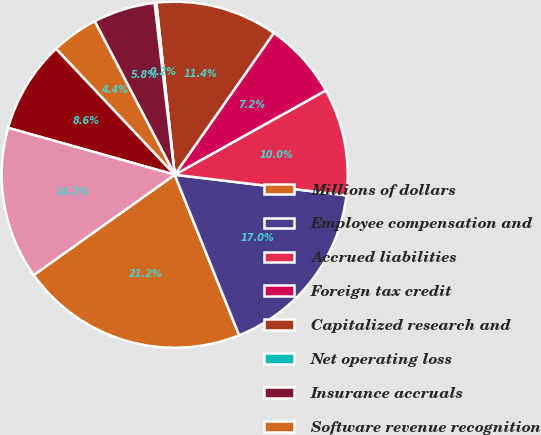Convert chart to OTSL. <chart><loc_0><loc_0><loc_500><loc_500><pie_chart><fcel>Millions of dollars<fcel>Employee compensation and<fcel>Accrued liabilities<fcel>Foreign tax credit<fcel>Capitalized research and<fcel>Net operating loss<fcel>Insurance accruals<fcel>Software revenue recognition<fcel>Inventory<fcel>Other<nl><fcel>21.23%<fcel>17.02%<fcel>10.0%<fcel>7.19%<fcel>11.4%<fcel>0.17%<fcel>5.79%<fcel>4.38%<fcel>8.6%<fcel>14.21%<nl></chart> 